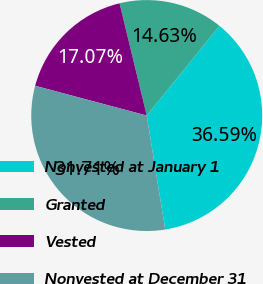Convert chart. <chart><loc_0><loc_0><loc_500><loc_500><pie_chart><fcel>Nonvested at January 1<fcel>Granted<fcel>Vested<fcel>Nonvested at December 31<nl><fcel>36.59%<fcel>14.63%<fcel>17.07%<fcel>31.71%<nl></chart> 